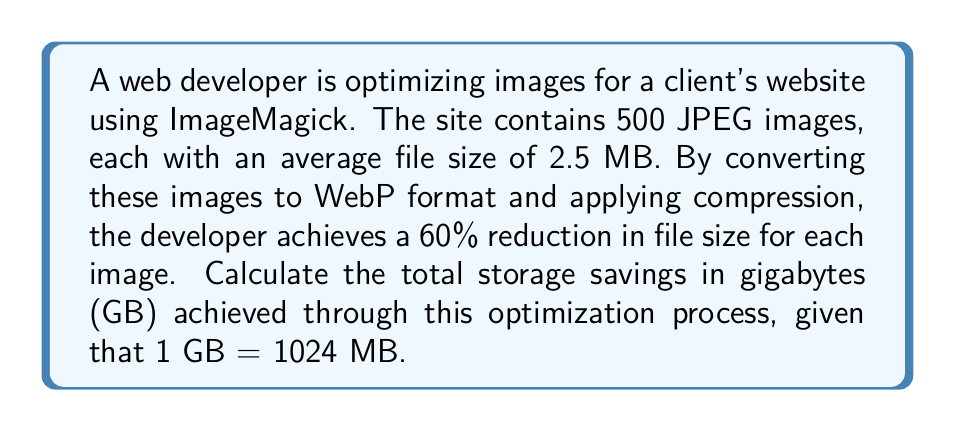Can you answer this question? To solve this problem, let's break it down into steps:

1. Calculate the total storage used by the original JPEG images:
   $$ \text{Total JPEG size} = 500 \text{ images} \times 2.5 \text{ MB} = 1250 \text{ MB} $$

2. Calculate the new size of each image after 60% reduction:
   $$ \text{New size per image} = 2.5 \text{ MB} \times (1 - 0.60) = 2.5 \text{ MB} \times 0.40 = 1 \text{ MB} $$

3. Calculate the total storage used by the optimized WebP images:
   $$ \text{Total WebP size} = 500 \text{ images} \times 1 \text{ MB} = 500 \text{ MB} $$

4. Calculate the storage savings in MB:
   $$ \text{Storage savings} = \text{Total JPEG size} - \text{Total WebP size} $$
   $$ \text{Storage savings} = 1250 \text{ MB} - 500 \text{ MB} = 750 \text{ MB} $$

5. Convert the storage savings from MB to GB:
   $$ \text{Storage savings in GB} = \frac{750 \text{ MB}}{1024 \text{ MB/GB}} \approx 0.732421875 \text{ GB} $$

Therefore, the total storage savings achieved through image format conversion and optimization is approximately 0.73 GB.
Answer: 0.73 GB 